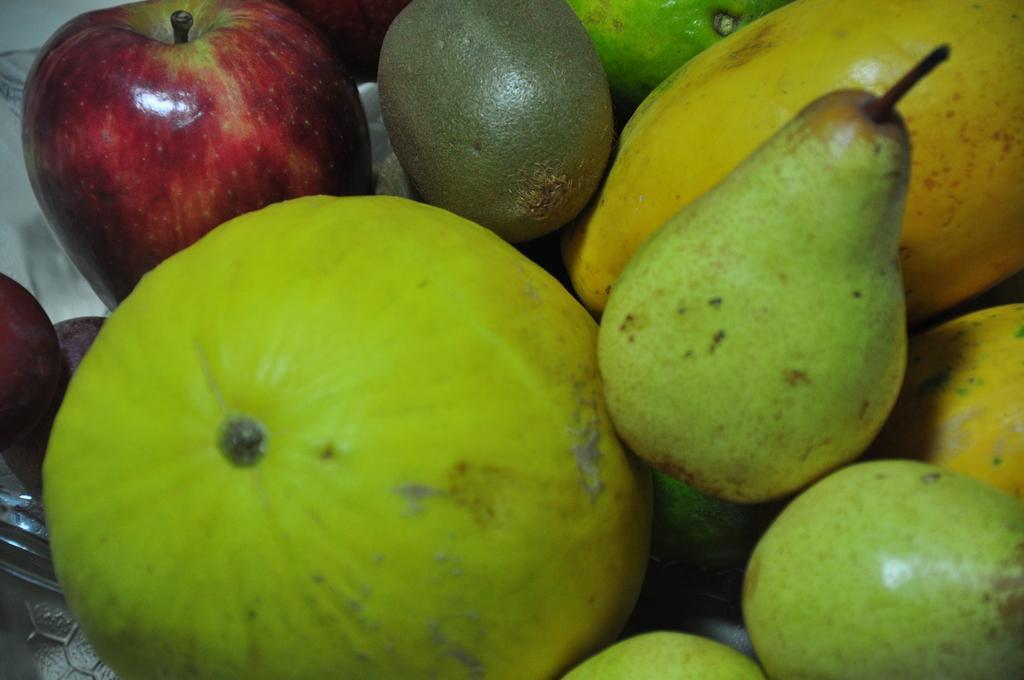In one or two sentences, can you explain what this image depicts? In this image we can see group of fruits placed in a bowl kept on the surface. 